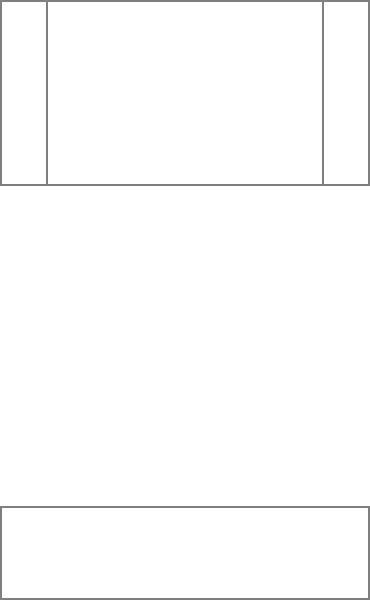Based on the IKEA-style furniture assembly diagram, which of the following represents the correct next step in assembling this armchair?

A) Attach the seat cushion
B) Add the legs to the base
C) Install the reclining mechanism
D) There are no more steps; the chair is complete Let's analyze the assembly process step-by-step:

1. In the first diagram (labeled "1"), we see four separate pieces: the base, the backrest, and two armrests.

2. In the second diagram (labeled "2"), we observe that the backrest has been attached to the base, forming the main structure of the chair. The armrests are still separate.

3. In the third diagram (labeled "3"), we see the complete chair with all pieces assembled: the base, backrest, and both armrests are now connected.

4. The question mark suggests that we need to determine if there's a next step after the third diagram.

Analyzing the progression, we can see that the assembly process is complete in the third diagram. All the visible components from the first step have been incorporated into the final product.

In typical IKEA-style furniture, once all the main structural components are assembled, the item is generally complete. There are no visible indications of missing parts like cushions, legs, or reclining mechanisms.
Answer: D) There are no more steps; the chair is complete 